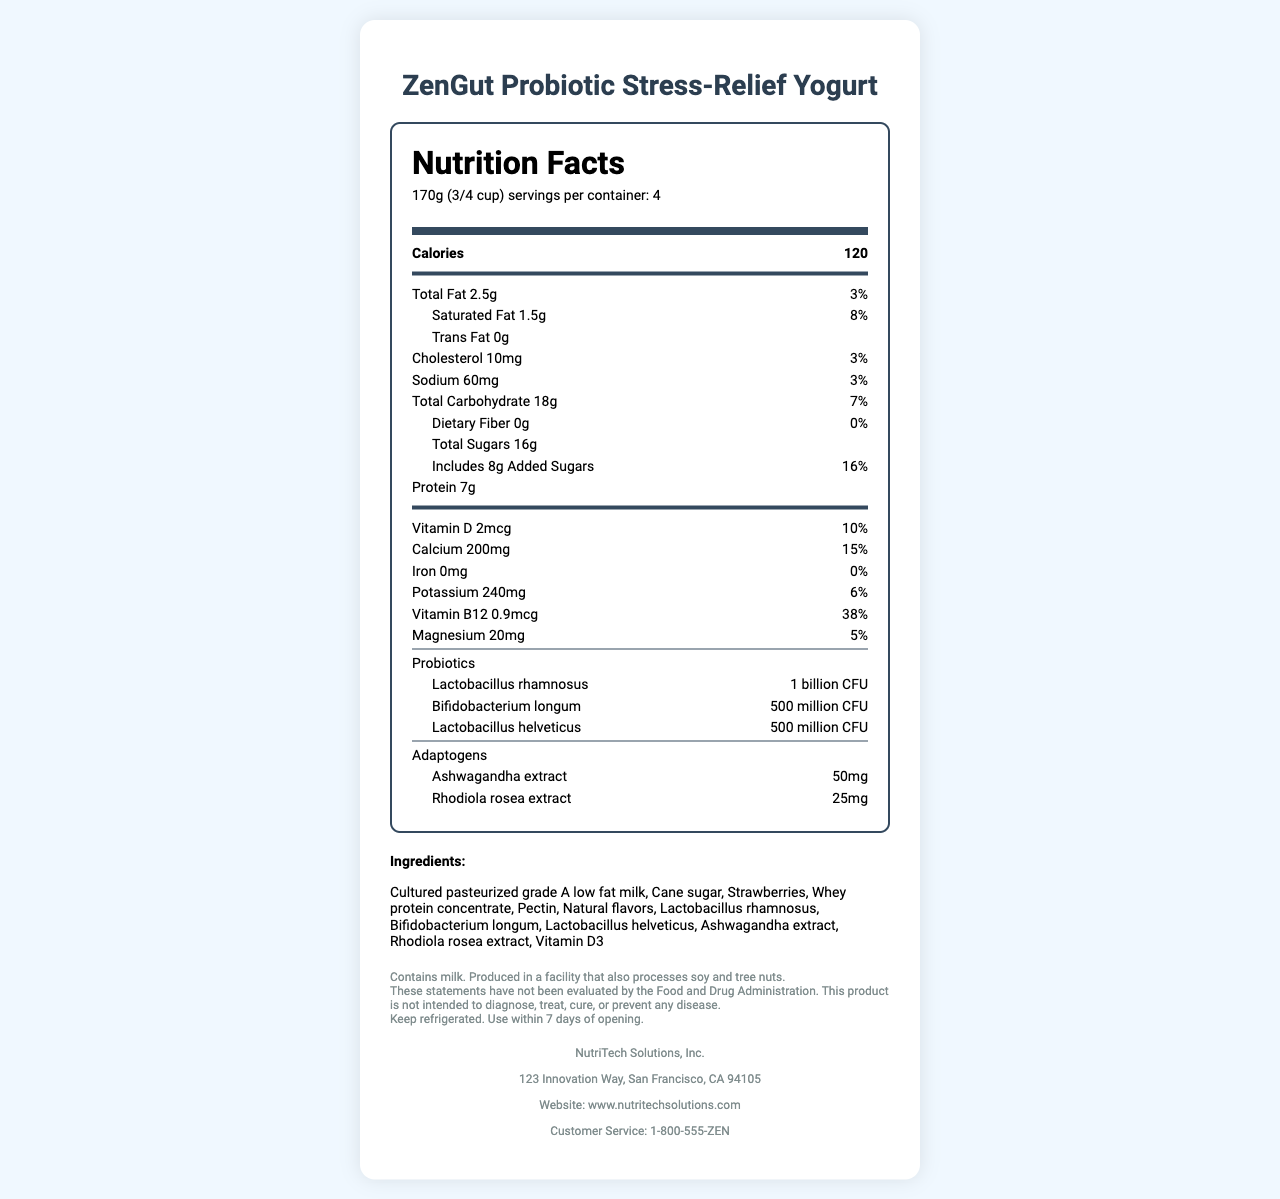what is the serving size for ZenGut Probiotic Stress-Relief Yogurt? The serving size is stated at the top of the nutrition label, right under the product name.
Answer: 170g (3/4 cup) how many calories are there per serving? The number of calories is listed prominently in the "Nutrition Facts" section.
Answer: 120 what is the percentage daily value of saturated fat per serving? This percentage is located next to the saturated fat amount in the nutritional label.
Answer: 8% how much protein does each serving provide? The protein content per serving is shown in the nutrients list.
Answer: 7g how much added sugar is in one serving? The amount of added sugar in one serving is indicated below the total sugars content.
Answer: 8g how many servings are there per container? A. 2 B. 4 C. 6 D. 8 The number of servings per container is mentioned near the top of the nutrition label under the serving size.
Answer: B. 4 what is the total fat content in one serving? A. 1g B. 2.5g C. 5g D. 10g The total fat content is shown at the beginning of the nutrient list.
Answer: B. 2.5g does the yogurt contain any dietary fiber? The nutrition facts label shows that the dietary fiber is 0g.
Answer: No is the yogurt suitable for someone with a milk allergy? The allergen info clearly states that the product contains milk.
Answer: No summarize the key elements of the ZenGut Probiotic Stress-Relief Yogurt Nutrition Facts Label. This summary includes nutritional information, key nutrients, allergen info, and product description as seen on the label.
Answer: The ZenGut Probiotic Stress-Relief Yogurt has a serving size of 170g (3/4 cup) with 4 servings per container. Each serving contains 120 calories, 2.5g of total fat, 1.5g of saturated fat, 0g of trans fat, 10mg of cholesterol, 60mg of sodium, 18g of total carbohydrates, 0g of dietary fiber, 16g of total sugars including 8g of added sugars, and 7g of protein. The yogurt is enriched with vitamins and minerals like Vitamin D, Calcium, Potassium, Vitamin B12, and Magnesium. It also contains probiotics and adaptogens for gut health and stress relief. Ingredients include cultured pasteurized grade A low-fat milk, cane sugar, strawberries, whey protein concentrate, and natural flavors. Allergen information notes the product contains milk and is produced in a facility that processes soy and tree nuts. what is the amount of Vitamin B12 in each serving? The amount of Vitamin B12 is listed in the nutrients section.
Answer: 0.9mcg can this yogurt treat diagnosed medical conditions? The legal disclaimer states that the product is not intended to diagnose, treat, cure, or prevent any disease.
Answer: No which probiotic strain has the highest CFU count in the yogurt? The Lactobacillus rhamnosus strain has the highest count with 1 billion CFU.
Answer: Lactobacillus rhamnosus how many total carbohydrates are in one serving of the yogurt? The total carbohydrates content is listed in the nutrients section.
Answer: 18g what is the shelf life of the yogurt once opened? The storage instructions specify to use within 7 days of opening.
Answer: 7 days how much cholesterol does each serving of the yogurt contain? A. 15mg B. 10mg C. 5mg D. 0mg The cholesterol amount per serving is listed in the nutrients section.
Answer: B. 10mg what is the function of ashwagandha extract in the yogurt? While the document states the presence of ashwagandha extract, it does not elaborate on its specific function within the yogurt.
Answer: Not enough information 